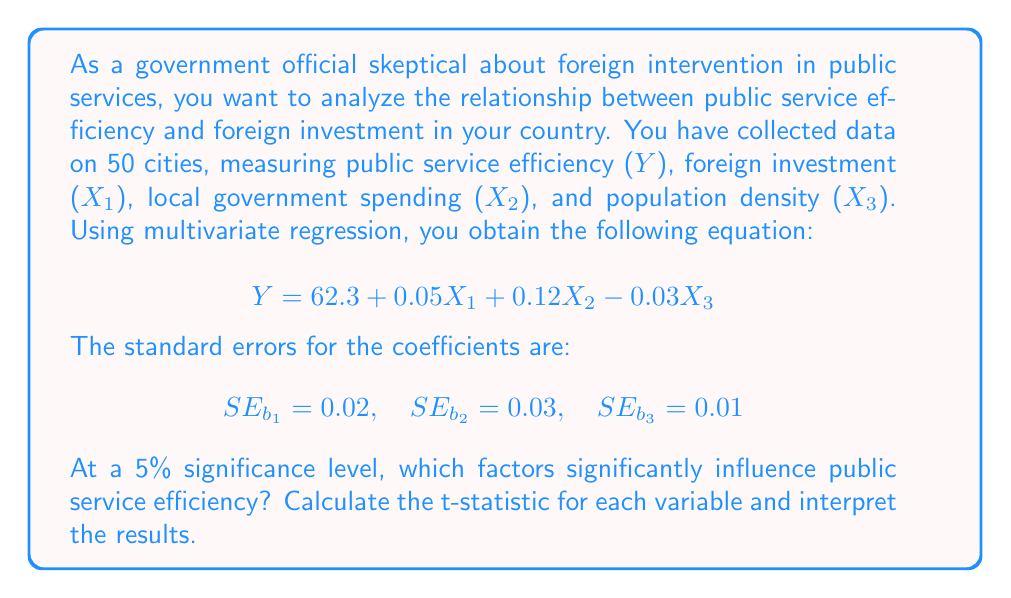Solve this math problem. To determine which factors significantly influence public service efficiency, we need to conduct t-tests for each coefficient. The steps are as follows:

1. Calculate the t-statistic for each coefficient:
   $t = \frac{b_i}{SE_{b_i}}$

2. Compare the absolute value of each t-statistic to the critical t-value. At a 5% significance level with 46 degrees of freedom (50 observations - 4 parameters), the critical t-value is approximately 2.013.

For X1 (Foreign Investment):
$$t_{X1} = \frac{0.05}{0.02} = 2.5$$

For X2 (Local Government Spending):
$$t_{X2} = \frac{0.12}{0.03} = 4$$

For X3 (Population Density):
$$t_{X3} = \frac{-0.03}{0.01} = -3$$

3. Interpret the results:
   - If |t| > 2.013, reject the null hypothesis and conclude the variable is significant.
   - If |t| ≤ 2.013, fail to reject the null hypothesis and conclude the variable is not significant.

For X1: |2.5| > 2.013, so foreign investment is significant.
For X2: |4| > 2.013, so local government spending is significant.
For X3: |-3| > 2.013, so population density is significant.
Answer: All three factors (foreign investment, local government spending, and population density) significantly influence public service efficiency at the 5% significance level, as their absolute t-statistics (2.5, 4, and 3, respectively) are all greater than the critical value of 2.013. 